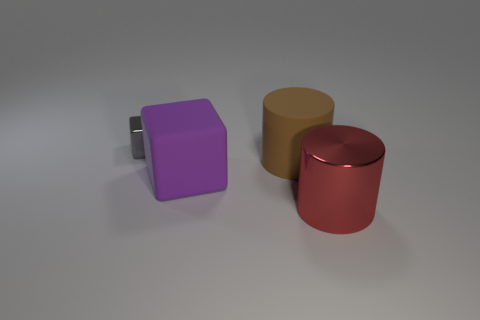Are the big thing that is in front of the large purple matte thing and the block to the right of the gray metallic object made of the same material?
Provide a succinct answer. No. Are the large brown thing that is on the right side of the purple object and the gray thing made of the same material?
Provide a short and direct response. No. What is the size of the thing to the left of the block that is in front of the small metal cube?
Provide a succinct answer. Small. There is a metallic object that is to the right of the metallic thing that is to the left of the big rubber thing that is in front of the brown thing; what shape is it?
Make the answer very short. Cylinder. The other object that is the same material as the purple thing is what size?
Your answer should be compact. Large. Are there more tiny things than metal objects?
Make the answer very short. No. What is the material of the brown object that is the same size as the rubber block?
Give a very brief answer. Rubber. Does the block that is in front of the brown object have the same size as the red cylinder?
Give a very brief answer. Yes. How many cubes are red rubber objects or large red objects?
Offer a very short reply. 0. There is a cube that is behind the brown cylinder; what material is it?
Provide a short and direct response. Metal. 